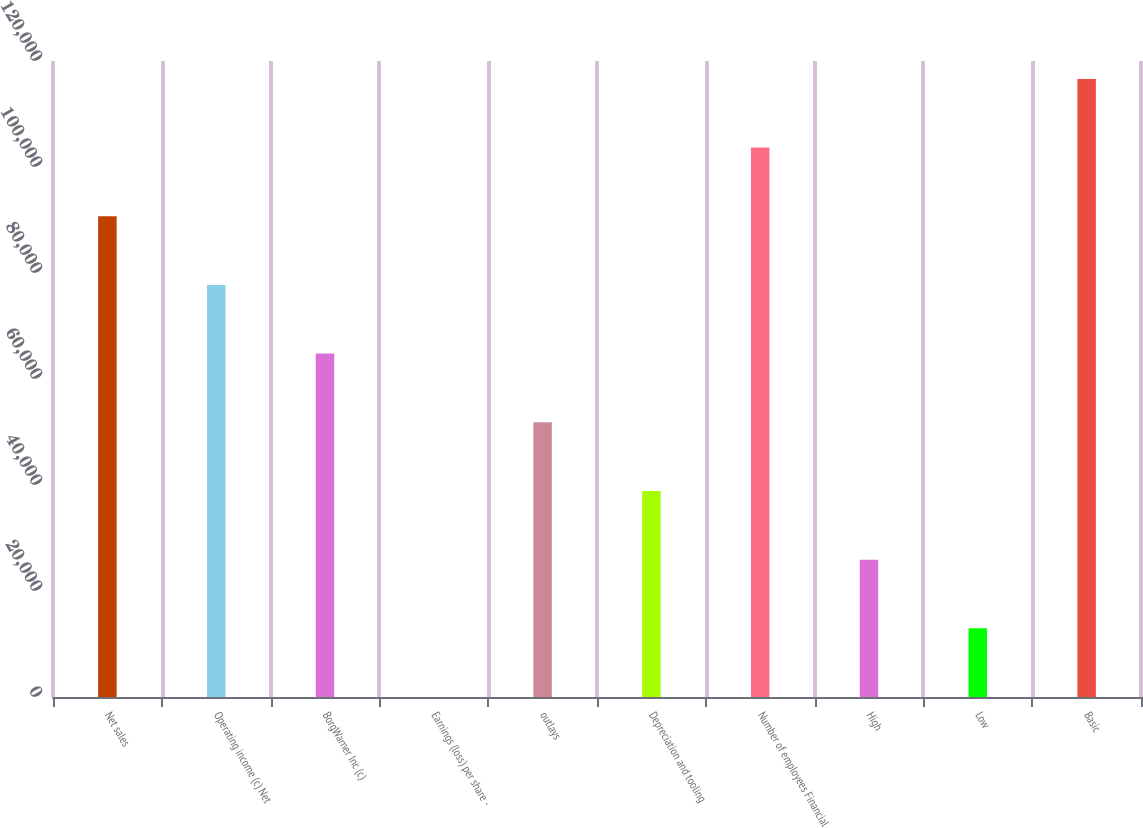<chart> <loc_0><loc_0><loc_500><loc_500><bar_chart><fcel>Net sales<fcel>Operating income (c) Net<fcel>BorgWarner Inc (c)<fcel>Earnings (loss) per share -<fcel>outlays<fcel>Depreciation and tooling<fcel>Number of employees Financial<fcel>High<fcel>Low<fcel>Basic<nl><fcel>90703.5<fcel>77746.3<fcel>64789.2<fcel>3.31<fcel>51832<fcel>38874.8<fcel>103661<fcel>25917.7<fcel>12960.5<fcel>116618<nl></chart> 